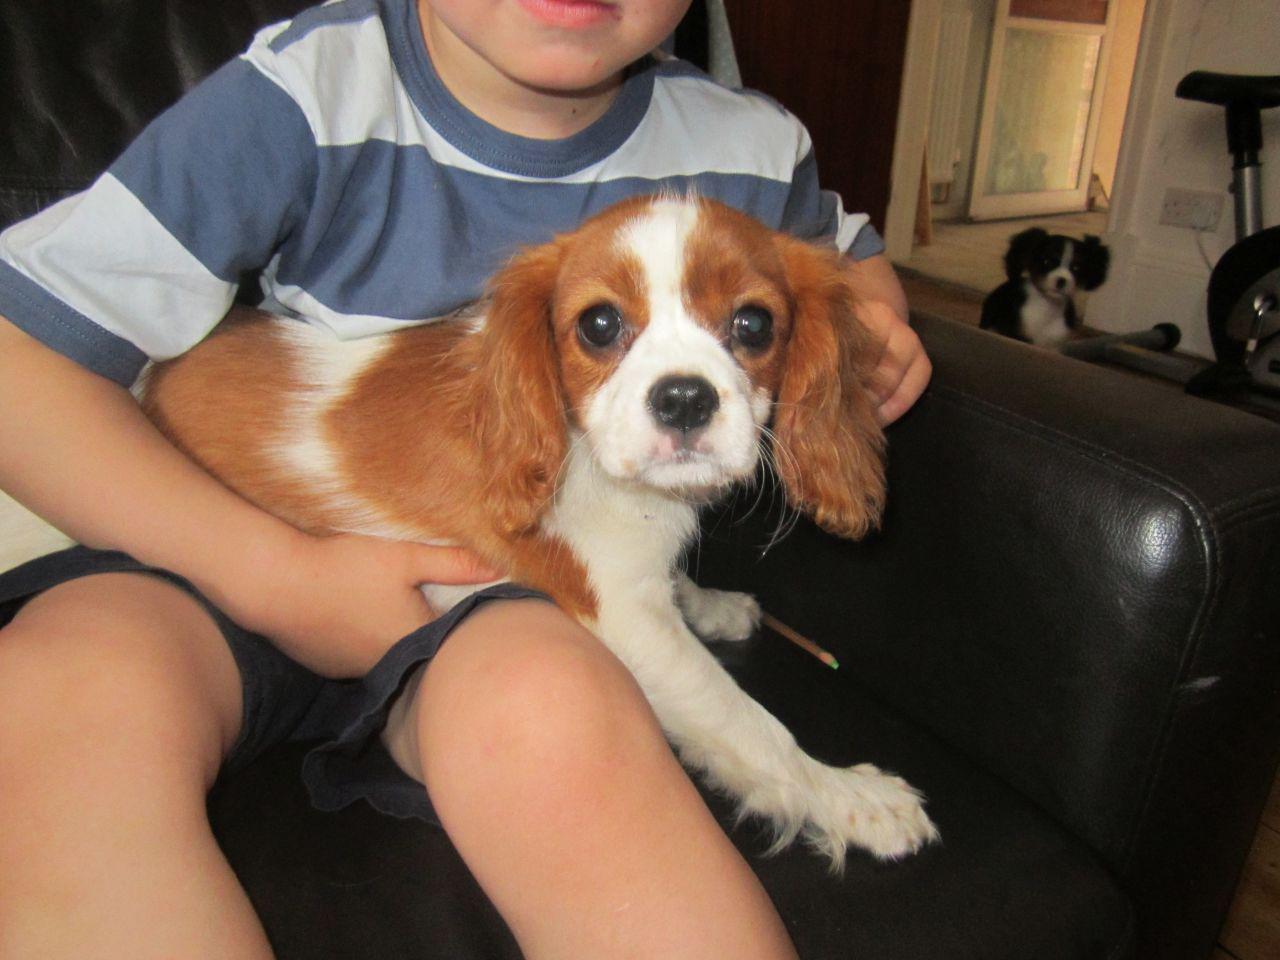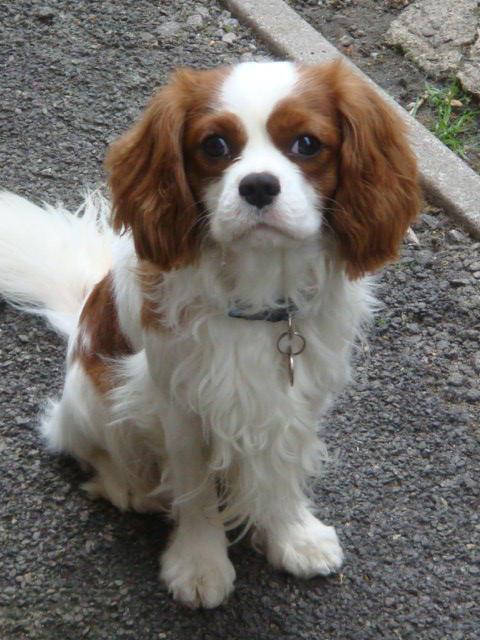The first image is the image on the left, the second image is the image on the right. Examine the images to the left and right. Is the description "At least 1 brown and white dog is in the grass." accurate? Answer yes or no. No. The first image is the image on the left, the second image is the image on the right. Considering the images on both sides, is "There is at least one dog on top of grass." valid? Answer yes or no. No. 